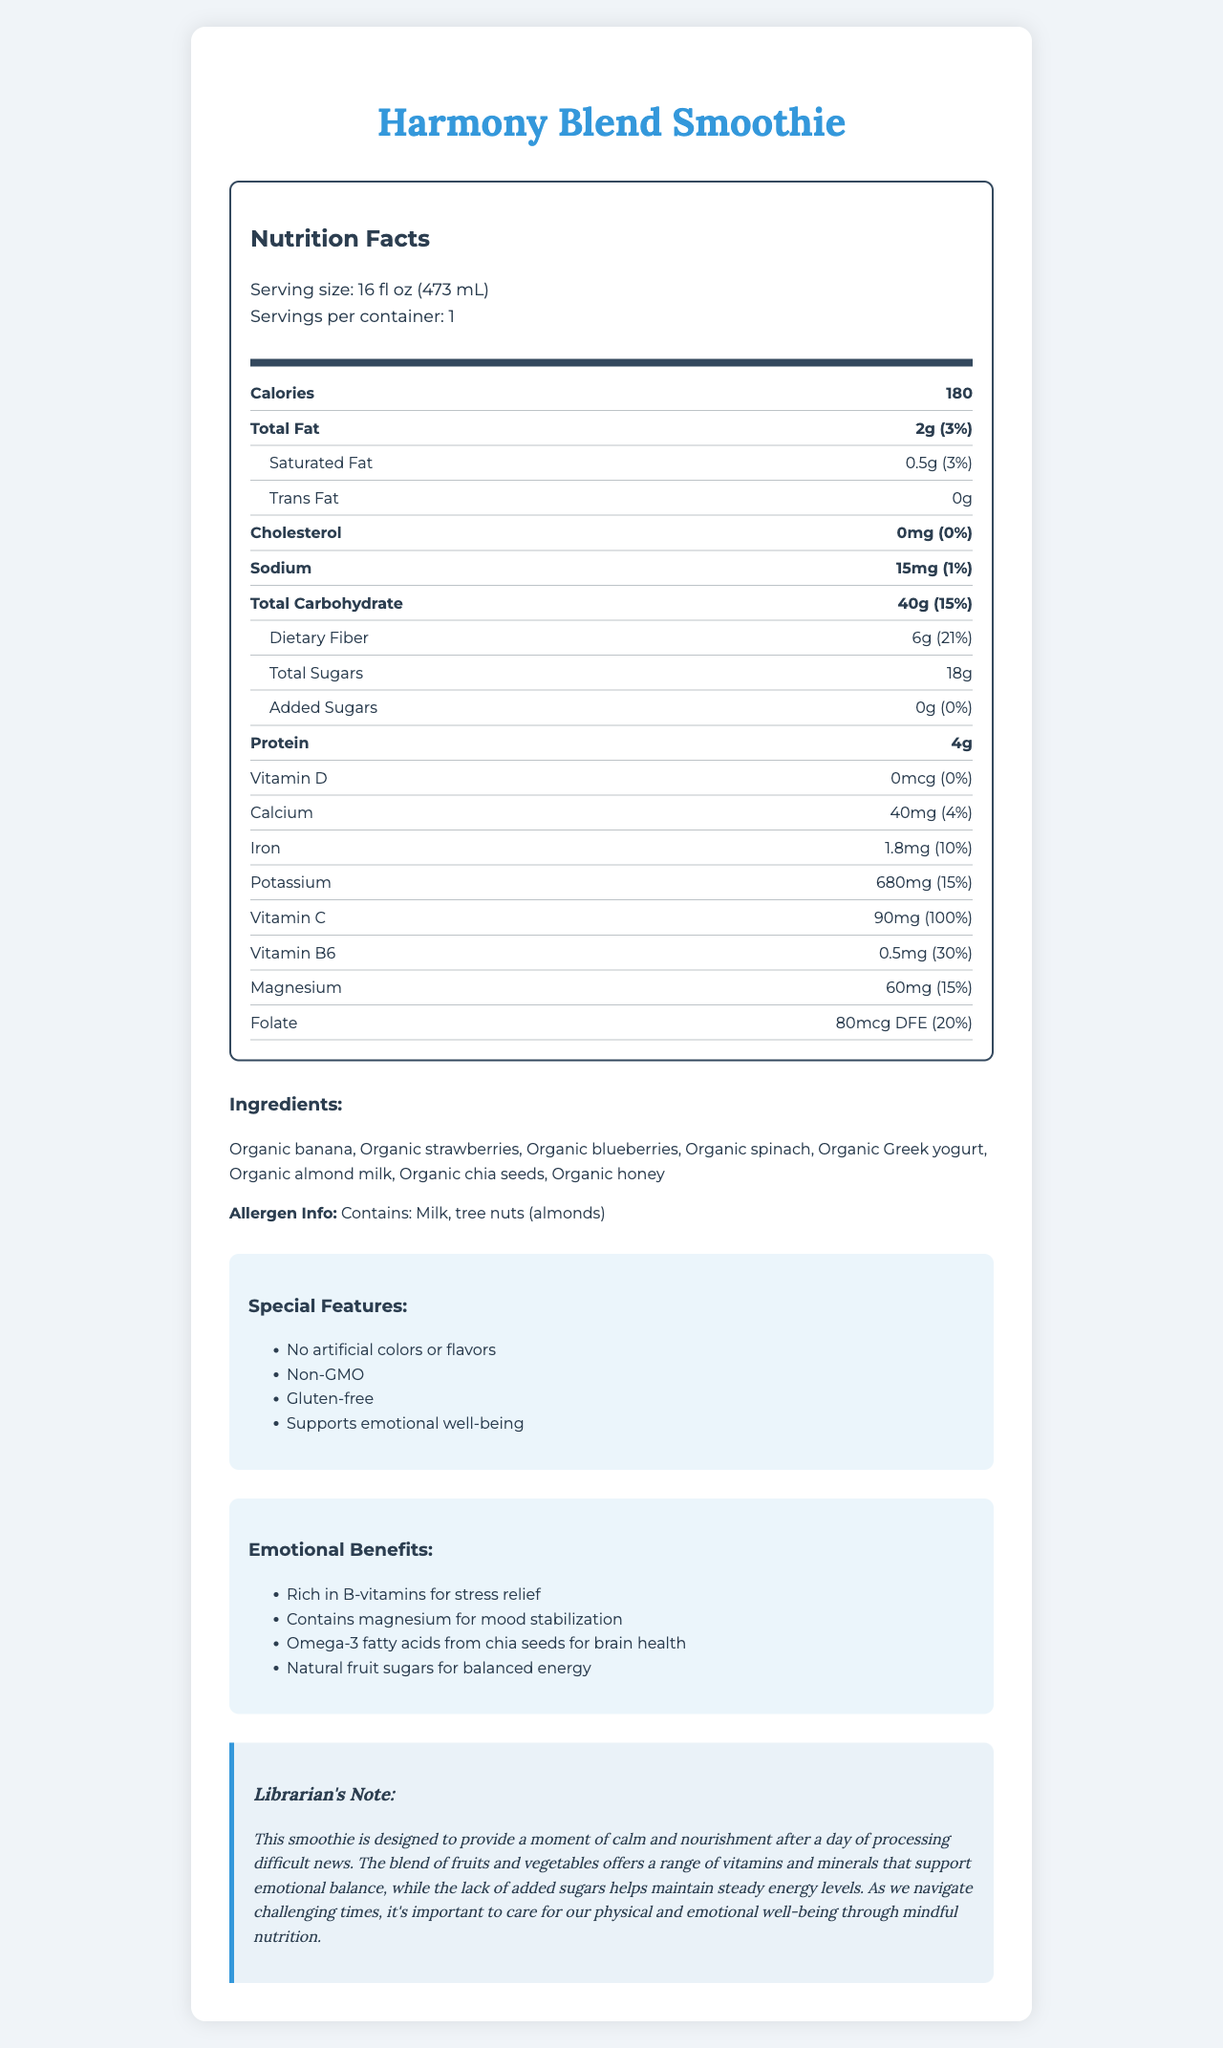how many calories are in a serving of Harmony Blend Smoothie? The nutritional facts list the calories as 180 for a 16 fl oz (473 mL) serving size.
Answer: 180 what is the serving size of the Harmony Blend Smoothie? The document specifies the serving size as 16 fl oz (473 mL).
Answer: 16 fl oz (473 mL) how many grams of dietary fiber are included in each serving? The dietary fiber content is listed as 6g in the nutrition facts section of the document.
Answer: 6g which vitamin is present in the greatest amount as a percentage of daily value? The Vitamin C amount is 90mg, providing 100% of the daily value, as indicated in the document.
Answer: Vitamin C what are the main ingredients of the Harmony Blend Smoothie? The ingredient list includes all these organic components.
Answer: Organic banana, Organic strawberries, Organic blueberries, Organic spinach, Organic Greek yogurt, Organic almond milk, Organic chia seeds, Organic honey what is the total carbohydrate content per serving? The total carbohydrate content is listed as 40g per serving in the nutrition facts.
Answer: 40g does the Harmony Blend Smoothie contain any added sugars? The document specifically lists the amount of added sugars as 0g.
Answer: No which nutrient helps support stress relief? The emotional benefits section mentions that the smoothie is rich in B-vitamins for stress relief.
Answer: B-vitamins which special feature is not associated with the Harmony Blend Smoothie? A. Non-GMO B. Gluten-free C. Contains artificial flavors D. No artificial colors The special features listed include "No artificial colors or flavors", "Non-GMO", and "Gluten-free", meaning that it does not contain artificial flavors.
Answer: C how many grams of protein are in the Harmony Blend Smoothie? The nutrition facts state that each serving contains 4 grams of protein.
Answer: 4g does the Harmony Blend Smoothie provide any vitamin D? The vitamin D content is listed as 0mcg, with 0% of the daily value.
Answer: No what is the allergen information for this product? A. Contains lactose B. Contains tree nuts (almonds) C. Contains gluten D. Contains soy The allergen information section indicates that the smoothie contains tree nuts (almonds) and milk.
Answer: B what is the main idea of the document? The document describes the nutritional content, ingredients, special features, and emotional benefits of the Harmony Blend Smoothie, emphasizing its qualities that support emotional well-being.
Answer: The Harmony Blend Smoothie is a vitamin-rich, low-sugar fruit smoothie designed to promote emotional balance and well-being. It includes organic ingredients, has no added sugars, and contains multiple nutrients that support stress relief, mood stabilization, and brain health. what is the total amount of sugars in the smoothie? The total sugars content is listed as 18g per serving.
Answer: 18g what specific amounts of omega-3 fatty acids does the Harmony Blend Smoothie contain? The document mentions omega-3 fatty acids from chia seeds as an emotional benefit but does not provide specific amounts.
Answer: Not enough information what percentage of daily value does the magnesium content make up? The document lists the magnesium content as 60mg, which is 15% of the daily value.
Answer: 15% is the Harmony Blend Smoothie gluten-free? The special features section clearly states that the smoothie is gluten-free.
Answer: Yes 